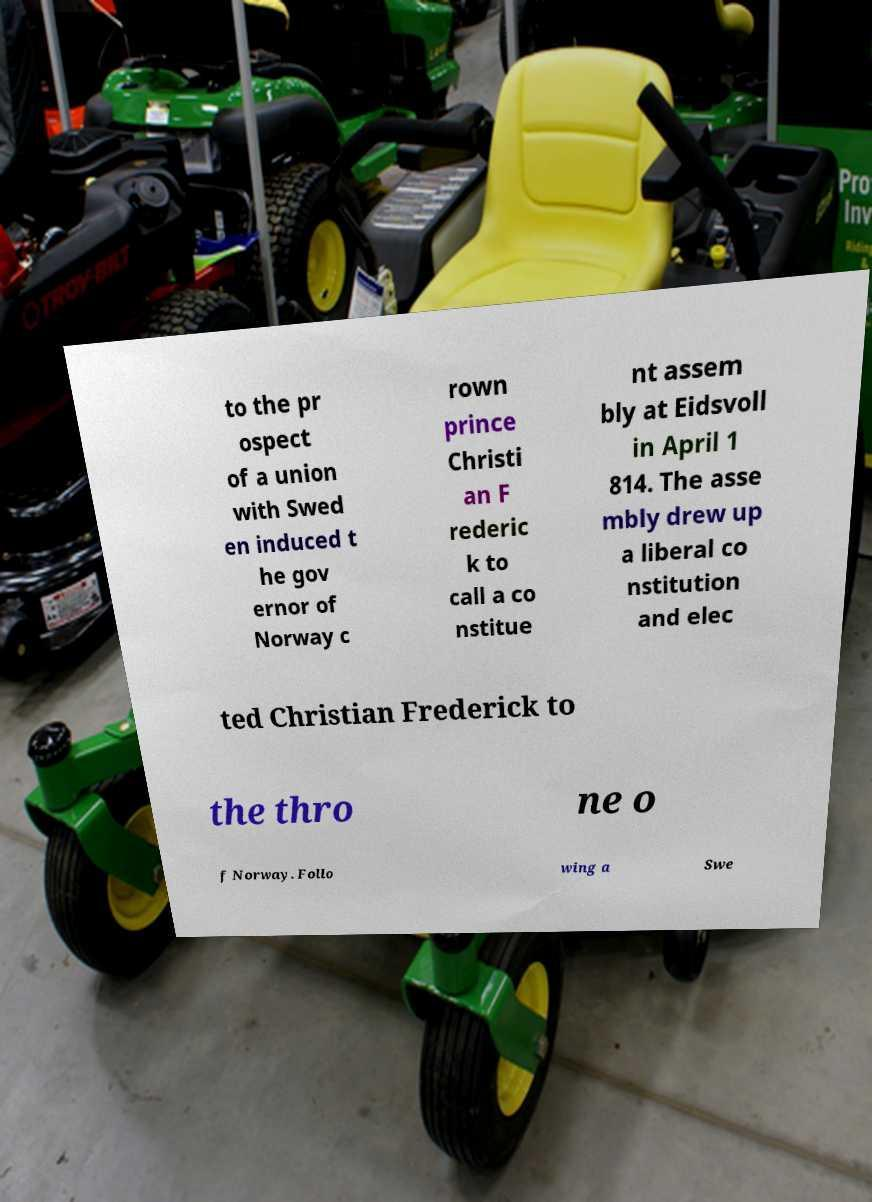Could you assist in decoding the text presented in this image and type it out clearly? to the pr ospect of a union with Swed en induced t he gov ernor of Norway c rown prince Christi an F rederic k to call a co nstitue nt assem bly at Eidsvoll in April 1 814. The asse mbly drew up a liberal co nstitution and elec ted Christian Frederick to the thro ne o f Norway. Follo wing a Swe 